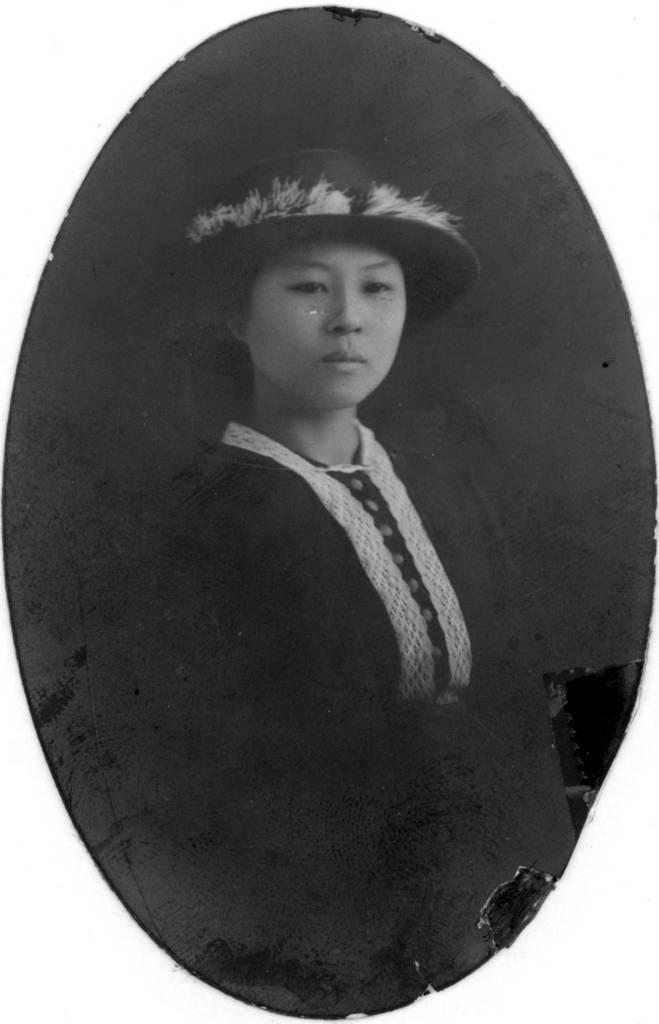What type of image is being described? The image is an old black and white picture. Can you describe the main subject of the image? There is a woman in the image. What type of sea creature is visible in the woman's hair in the image? There is no sea creature visible in the woman's hair in the image, as it is an old black and white picture of a woman. 